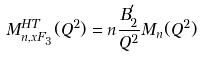Convert formula to latex. <formula><loc_0><loc_0><loc_500><loc_500>M _ { n , x F _ { 3 } } ^ { H T } ( Q ^ { 2 } ) = n \frac { B _ { 2 } ^ { ^ { \prime } } } { Q ^ { 2 } } M _ { n } ( Q ^ { 2 } )</formula> 